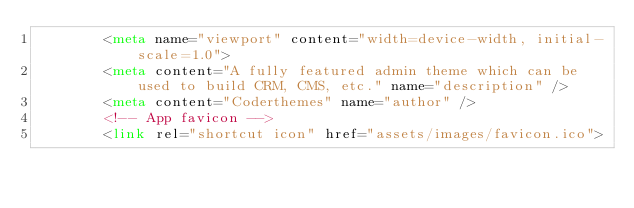<code> <loc_0><loc_0><loc_500><loc_500><_HTML_>        <meta name="viewport" content="width=device-width, initial-scale=1.0">
        <meta content="A fully featured admin theme which can be used to build CRM, CMS, etc." name="description" />
        <meta content="Coderthemes" name="author" />
        <!-- App favicon -->
        <link rel="shortcut icon" href="assets/images/favicon.ico">
</code> 